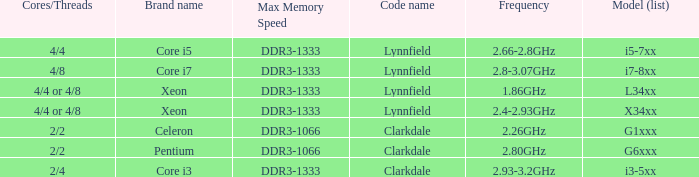What frequency does model L34xx use? 1.86GHz. 